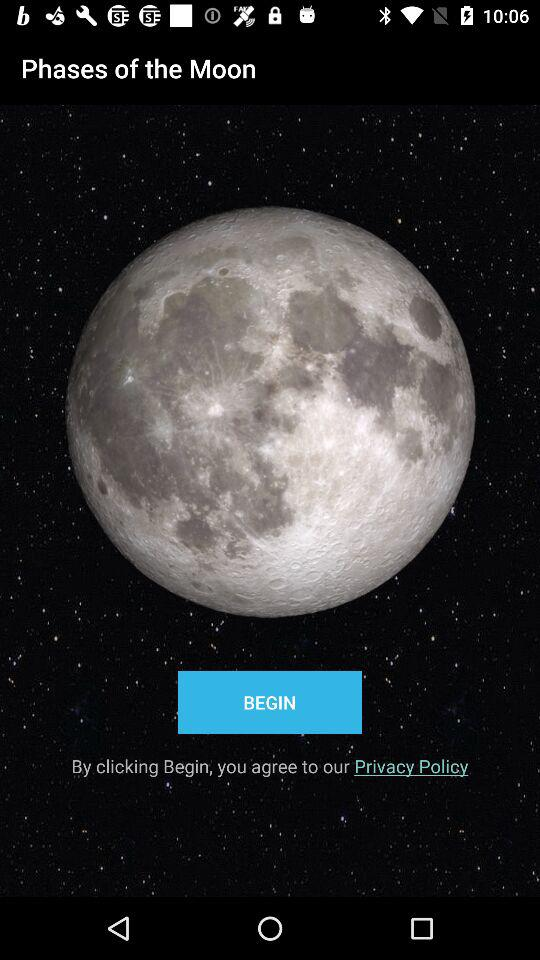What is the name of the application? The name of the application is "Phases of the Moon". 